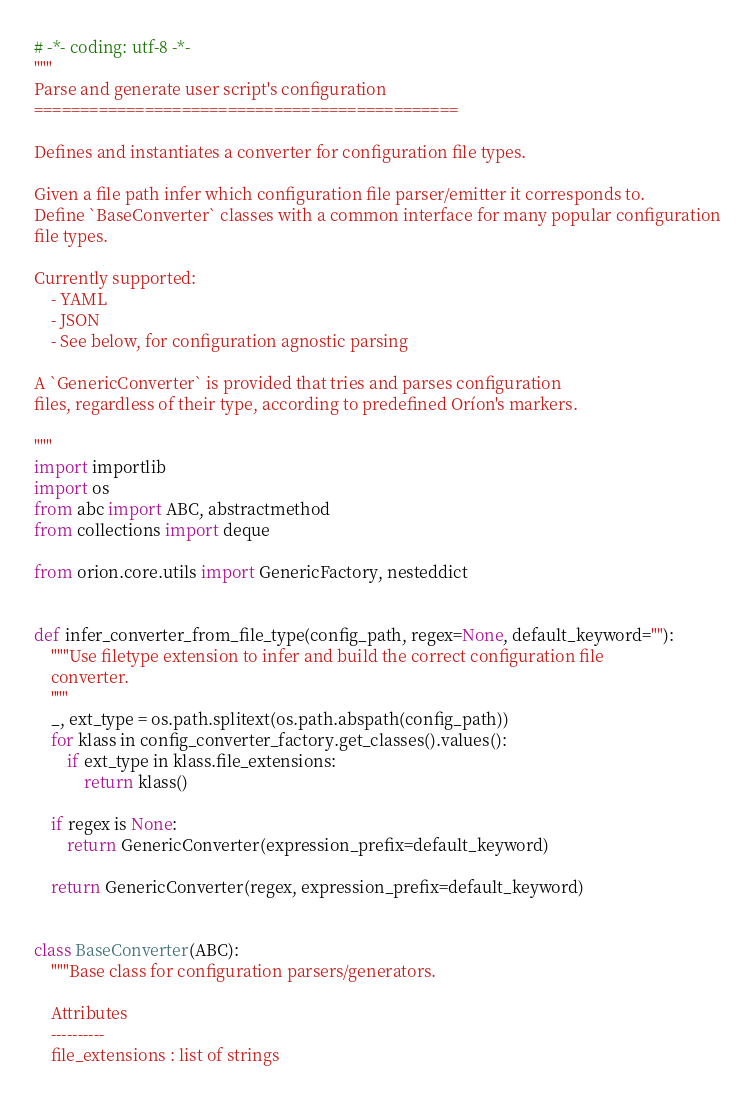Convert code to text. <code><loc_0><loc_0><loc_500><loc_500><_Python_># -*- coding: utf-8 -*-
"""
Parse and generate user script's configuration
==============================================

Defines and instantiates a converter for configuration file types.

Given a file path infer which configuration file parser/emitter it corresponds to.
Define `BaseConverter` classes with a common interface for many popular configuration
file types.

Currently supported:
    - YAML
    - JSON
    - See below, for configuration agnostic parsing

A `GenericConverter` is provided that tries and parses configuration
files, regardless of their type, according to predefined Oríon's markers.

"""
import importlib
import os
from abc import ABC, abstractmethod
from collections import deque

from orion.core.utils import GenericFactory, nesteddict


def infer_converter_from_file_type(config_path, regex=None, default_keyword=""):
    """Use filetype extension to infer and build the correct configuration file
    converter.
    """
    _, ext_type = os.path.splitext(os.path.abspath(config_path))
    for klass in config_converter_factory.get_classes().values():
        if ext_type in klass.file_extensions:
            return klass()

    if regex is None:
        return GenericConverter(expression_prefix=default_keyword)

    return GenericConverter(regex, expression_prefix=default_keyword)


class BaseConverter(ABC):
    """Base class for configuration parsers/generators.

    Attributes
    ----------
    file_extensions : list of strings</code> 